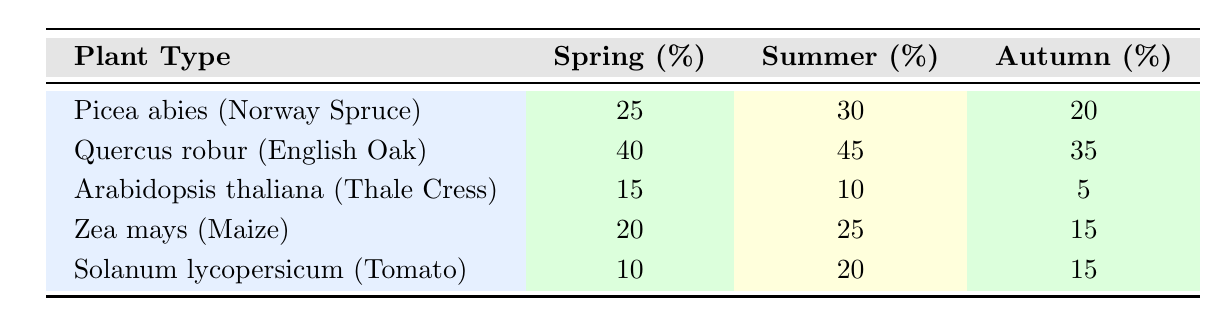What is the colonization rate for Quercus robur in summer? The table shows Quercus robur has a colonization rate of 45% in the summer season.
Answer: 45% Which plant type has the highest colonization rate in spring? According to the table, Quercus robur has the highest colonization rate in spring with 40%.
Answer: Quercus robur What is the average colonization rate for Picea abies across all seasons? The table displays the colonization rates for Picea abies as 25% in spring, 30% in summer, and 20% in autumn. To find the average: (25 + 30 + 20) / 3 = 75 / 3 = 25%.
Answer: 25% Is the colonization rate for Arabidopsis thaliana higher in spring than in autumn? The rates are 15% in spring and 5% in autumn. Since 15% is greater than 5%, it is true that the rate is higher in spring.
Answer: Yes What is the total colonization rate for Zea mays across all seasons? The table lists the colonization rates for Zea mays as 20% in spring, 25% in summer, and 15% in autumn. To get the total, we add them: 20 + 25 + 15 = 60%.
Answer: 60% Which plant type demonstrates the lowest colonization rate in summer? From the table, Arabidopsis thaliana has the lowest colonization rate in summer at 10%.
Answer: Arabidopsis thaliana Is there a pattern in colonization rates decreasing from spring to autumn for any plant type? Observing the table, only Arabidopsis thaliana shows a consistent decrease with rates of 15% in spring, 10% in summer, and 5% in autumn. Thus, this plant type shows a clear declining pattern.
Answer: Yes What is the difference in colonization rates between Quercus robur in summer and Solanum lycopersicum in spring? The colonization rate for Quercus robur in summer is 45%, and for Solanum lycopersicum in spring, it is 10%. The difference is calculated as 45 - 10 = 35%.
Answer: 35% 